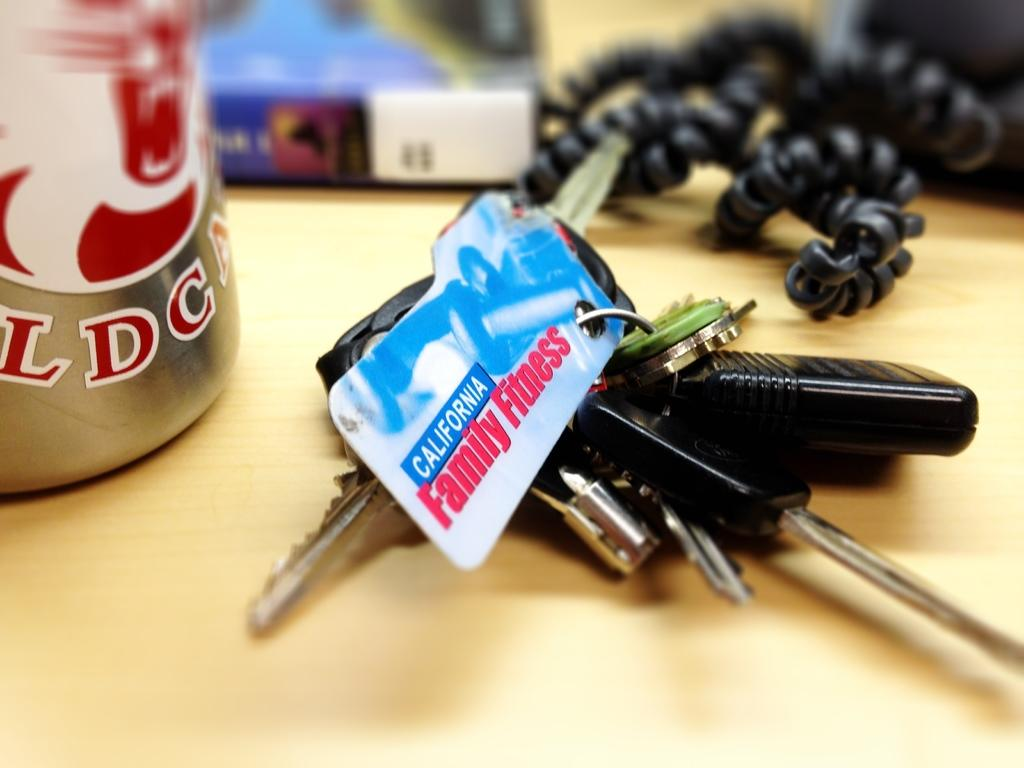What can be observed about the background of the image? The background of the image is blurred. What type of platform is present in the image? There is a wooden platform in the image. What items can be seen on the wooden platform? There is a keychain, keys, a handset cord, and an unspecified object on the platform. What type of meal is being prepared on the wooden platform in the image? There is no meal preparation visible in the image; it features a wooden platform with various items on it. Can you hear the person laughing while looking at the image? There is no person or sound present in the image, so it is not possible to determine if someone is laughing. 